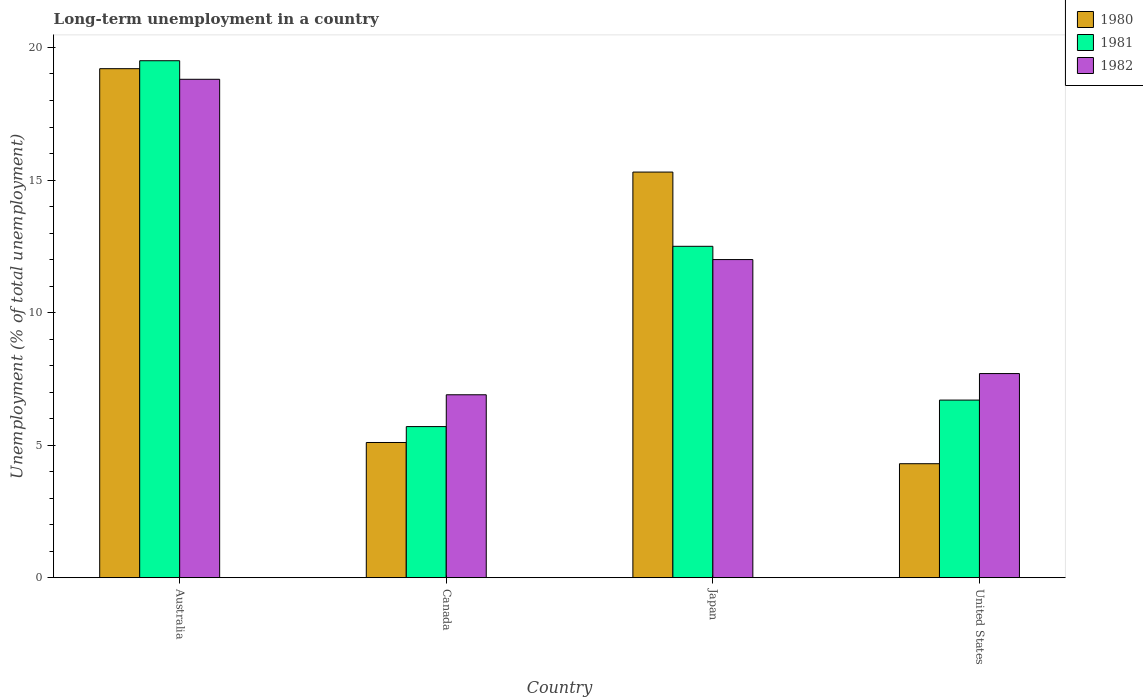How many different coloured bars are there?
Make the answer very short. 3. How many groups of bars are there?
Your answer should be very brief. 4. Are the number of bars on each tick of the X-axis equal?
Provide a short and direct response. Yes. How many bars are there on the 4th tick from the right?
Give a very brief answer. 3. What is the percentage of long-term unemployed population in 1982 in Australia?
Provide a succinct answer. 18.8. Across all countries, what is the maximum percentage of long-term unemployed population in 1980?
Give a very brief answer. 19.2. Across all countries, what is the minimum percentage of long-term unemployed population in 1981?
Make the answer very short. 5.7. What is the total percentage of long-term unemployed population in 1981 in the graph?
Ensure brevity in your answer.  44.4. What is the difference between the percentage of long-term unemployed population in 1981 in Australia and that in Japan?
Your response must be concise. 7. What is the difference between the percentage of long-term unemployed population in 1982 in Canada and the percentage of long-term unemployed population in 1981 in Australia?
Give a very brief answer. -12.6. What is the average percentage of long-term unemployed population in 1982 per country?
Your answer should be compact. 11.35. What is the difference between the percentage of long-term unemployed population of/in 1981 and percentage of long-term unemployed population of/in 1982 in United States?
Give a very brief answer. -1. What is the ratio of the percentage of long-term unemployed population in 1982 in Canada to that in Japan?
Your answer should be compact. 0.58. Is the percentage of long-term unemployed population in 1982 in Australia less than that in Canada?
Make the answer very short. No. Is the difference between the percentage of long-term unemployed population in 1981 in Australia and United States greater than the difference between the percentage of long-term unemployed population in 1982 in Australia and United States?
Your response must be concise. Yes. What is the difference between the highest and the second highest percentage of long-term unemployed population in 1982?
Your answer should be very brief. 6.8. What is the difference between the highest and the lowest percentage of long-term unemployed population in 1980?
Your answer should be compact. 14.9. Is the sum of the percentage of long-term unemployed population in 1980 in Canada and Japan greater than the maximum percentage of long-term unemployed population in 1981 across all countries?
Provide a succinct answer. Yes. What does the 2nd bar from the left in United States represents?
Your answer should be very brief. 1981. Are all the bars in the graph horizontal?
Your answer should be compact. No. How many countries are there in the graph?
Your answer should be very brief. 4. What is the difference between two consecutive major ticks on the Y-axis?
Your response must be concise. 5. Are the values on the major ticks of Y-axis written in scientific E-notation?
Provide a short and direct response. No. Does the graph contain grids?
Ensure brevity in your answer.  No. How many legend labels are there?
Offer a very short reply. 3. How are the legend labels stacked?
Provide a short and direct response. Vertical. What is the title of the graph?
Ensure brevity in your answer.  Long-term unemployment in a country. What is the label or title of the X-axis?
Make the answer very short. Country. What is the label or title of the Y-axis?
Provide a short and direct response. Unemployment (% of total unemployment). What is the Unemployment (% of total unemployment) of 1980 in Australia?
Provide a short and direct response. 19.2. What is the Unemployment (% of total unemployment) of 1981 in Australia?
Make the answer very short. 19.5. What is the Unemployment (% of total unemployment) of 1982 in Australia?
Offer a very short reply. 18.8. What is the Unemployment (% of total unemployment) in 1980 in Canada?
Offer a very short reply. 5.1. What is the Unemployment (% of total unemployment) of 1981 in Canada?
Ensure brevity in your answer.  5.7. What is the Unemployment (% of total unemployment) in 1982 in Canada?
Ensure brevity in your answer.  6.9. What is the Unemployment (% of total unemployment) in 1980 in Japan?
Provide a succinct answer. 15.3. What is the Unemployment (% of total unemployment) of 1980 in United States?
Your answer should be compact. 4.3. What is the Unemployment (% of total unemployment) in 1981 in United States?
Keep it short and to the point. 6.7. What is the Unemployment (% of total unemployment) of 1982 in United States?
Your answer should be compact. 7.7. Across all countries, what is the maximum Unemployment (% of total unemployment) in 1980?
Ensure brevity in your answer.  19.2. Across all countries, what is the maximum Unemployment (% of total unemployment) in 1981?
Your response must be concise. 19.5. Across all countries, what is the maximum Unemployment (% of total unemployment) in 1982?
Provide a succinct answer. 18.8. Across all countries, what is the minimum Unemployment (% of total unemployment) in 1980?
Provide a succinct answer. 4.3. Across all countries, what is the minimum Unemployment (% of total unemployment) in 1981?
Give a very brief answer. 5.7. Across all countries, what is the minimum Unemployment (% of total unemployment) of 1982?
Make the answer very short. 6.9. What is the total Unemployment (% of total unemployment) in 1980 in the graph?
Give a very brief answer. 43.9. What is the total Unemployment (% of total unemployment) in 1981 in the graph?
Keep it short and to the point. 44.4. What is the total Unemployment (% of total unemployment) of 1982 in the graph?
Offer a terse response. 45.4. What is the difference between the Unemployment (% of total unemployment) in 1981 in Australia and that in Japan?
Your answer should be very brief. 7. What is the difference between the Unemployment (% of total unemployment) in 1982 in Australia and that in Japan?
Provide a short and direct response. 6.8. What is the difference between the Unemployment (% of total unemployment) of 1981 in Canada and that in Japan?
Offer a terse response. -6.8. What is the difference between the Unemployment (% of total unemployment) in 1982 in Canada and that in Japan?
Offer a very short reply. -5.1. What is the difference between the Unemployment (% of total unemployment) of 1980 in Canada and that in United States?
Your response must be concise. 0.8. What is the difference between the Unemployment (% of total unemployment) of 1982 in Canada and that in United States?
Make the answer very short. -0.8. What is the difference between the Unemployment (% of total unemployment) in 1980 in Japan and that in United States?
Ensure brevity in your answer.  11. What is the difference between the Unemployment (% of total unemployment) in 1981 in Japan and that in United States?
Your answer should be compact. 5.8. What is the difference between the Unemployment (% of total unemployment) of 1982 in Japan and that in United States?
Provide a succinct answer. 4.3. What is the difference between the Unemployment (% of total unemployment) in 1980 in Australia and the Unemployment (% of total unemployment) in 1981 in Canada?
Provide a succinct answer. 13.5. What is the difference between the Unemployment (% of total unemployment) of 1980 in Australia and the Unemployment (% of total unemployment) of 1982 in Japan?
Keep it short and to the point. 7.2. What is the difference between the Unemployment (% of total unemployment) in 1981 in Australia and the Unemployment (% of total unemployment) in 1982 in Japan?
Provide a succinct answer. 7.5. What is the difference between the Unemployment (% of total unemployment) of 1980 in Canada and the Unemployment (% of total unemployment) of 1981 in Japan?
Offer a very short reply. -7.4. What is the difference between the Unemployment (% of total unemployment) in 1980 in Canada and the Unemployment (% of total unemployment) in 1982 in Japan?
Keep it short and to the point. -6.9. What is the difference between the Unemployment (% of total unemployment) in 1981 in Canada and the Unemployment (% of total unemployment) in 1982 in United States?
Provide a succinct answer. -2. What is the difference between the Unemployment (% of total unemployment) in 1980 in Japan and the Unemployment (% of total unemployment) in 1981 in United States?
Your answer should be very brief. 8.6. What is the difference between the Unemployment (% of total unemployment) of 1980 in Japan and the Unemployment (% of total unemployment) of 1982 in United States?
Keep it short and to the point. 7.6. What is the difference between the Unemployment (% of total unemployment) of 1981 in Japan and the Unemployment (% of total unemployment) of 1982 in United States?
Provide a short and direct response. 4.8. What is the average Unemployment (% of total unemployment) in 1980 per country?
Provide a succinct answer. 10.97. What is the average Unemployment (% of total unemployment) of 1981 per country?
Your response must be concise. 11.1. What is the average Unemployment (% of total unemployment) in 1982 per country?
Ensure brevity in your answer.  11.35. What is the difference between the Unemployment (% of total unemployment) of 1981 and Unemployment (% of total unemployment) of 1982 in Australia?
Your response must be concise. 0.7. What is the difference between the Unemployment (% of total unemployment) of 1980 and Unemployment (% of total unemployment) of 1981 in Canada?
Provide a succinct answer. -0.6. What is the difference between the Unemployment (% of total unemployment) of 1981 and Unemployment (% of total unemployment) of 1982 in United States?
Provide a succinct answer. -1. What is the ratio of the Unemployment (% of total unemployment) of 1980 in Australia to that in Canada?
Make the answer very short. 3.76. What is the ratio of the Unemployment (% of total unemployment) of 1981 in Australia to that in Canada?
Ensure brevity in your answer.  3.42. What is the ratio of the Unemployment (% of total unemployment) of 1982 in Australia to that in Canada?
Provide a succinct answer. 2.72. What is the ratio of the Unemployment (% of total unemployment) of 1980 in Australia to that in Japan?
Provide a succinct answer. 1.25. What is the ratio of the Unemployment (% of total unemployment) of 1981 in Australia to that in Japan?
Provide a succinct answer. 1.56. What is the ratio of the Unemployment (% of total unemployment) of 1982 in Australia to that in Japan?
Offer a terse response. 1.57. What is the ratio of the Unemployment (% of total unemployment) in 1980 in Australia to that in United States?
Ensure brevity in your answer.  4.47. What is the ratio of the Unemployment (% of total unemployment) in 1981 in Australia to that in United States?
Your answer should be very brief. 2.91. What is the ratio of the Unemployment (% of total unemployment) in 1982 in Australia to that in United States?
Offer a very short reply. 2.44. What is the ratio of the Unemployment (% of total unemployment) of 1980 in Canada to that in Japan?
Keep it short and to the point. 0.33. What is the ratio of the Unemployment (% of total unemployment) of 1981 in Canada to that in Japan?
Provide a succinct answer. 0.46. What is the ratio of the Unemployment (% of total unemployment) of 1982 in Canada to that in Japan?
Make the answer very short. 0.57. What is the ratio of the Unemployment (% of total unemployment) in 1980 in Canada to that in United States?
Offer a terse response. 1.19. What is the ratio of the Unemployment (% of total unemployment) in 1981 in Canada to that in United States?
Your answer should be very brief. 0.85. What is the ratio of the Unemployment (% of total unemployment) of 1982 in Canada to that in United States?
Keep it short and to the point. 0.9. What is the ratio of the Unemployment (% of total unemployment) of 1980 in Japan to that in United States?
Provide a succinct answer. 3.56. What is the ratio of the Unemployment (% of total unemployment) of 1981 in Japan to that in United States?
Ensure brevity in your answer.  1.87. What is the ratio of the Unemployment (% of total unemployment) in 1982 in Japan to that in United States?
Provide a short and direct response. 1.56. What is the difference between the highest and the lowest Unemployment (% of total unemployment) of 1980?
Your response must be concise. 14.9. What is the difference between the highest and the lowest Unemployment (% of total unemployment) in 1982?
Your response must be concise. 11.9. 